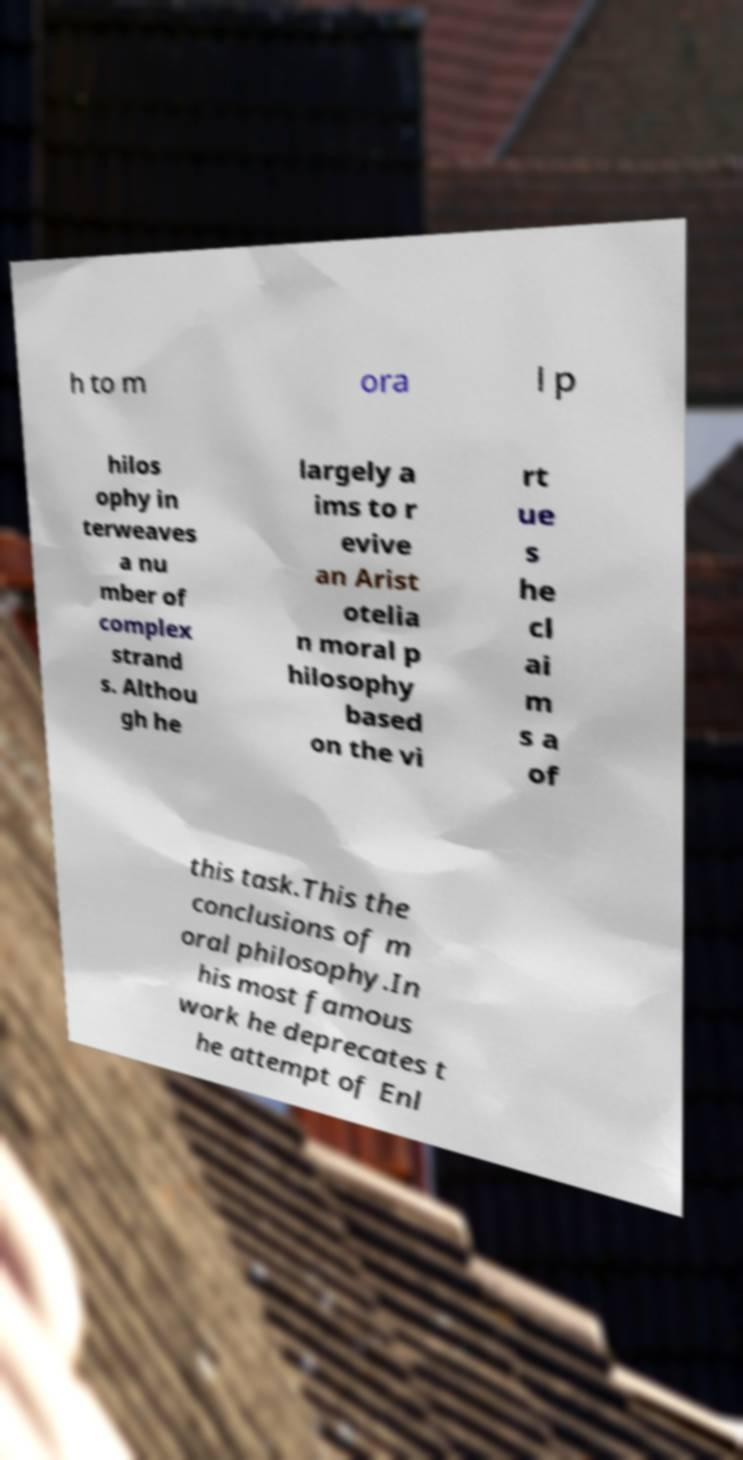There's text embedded in this image that I need extracted. Can you transcribe it verbatim? h to m ora l p hilos ophy in terweaves a nu mber of complex strand s. Althou gh he largely a ims to r evive an Arist otelia n moral p hilosophy based on the vi rt ue s he cl ai m s a of this task.This the conclusions of m oral philosophy.In his most famous work he deprecates t he attempt of Enl 